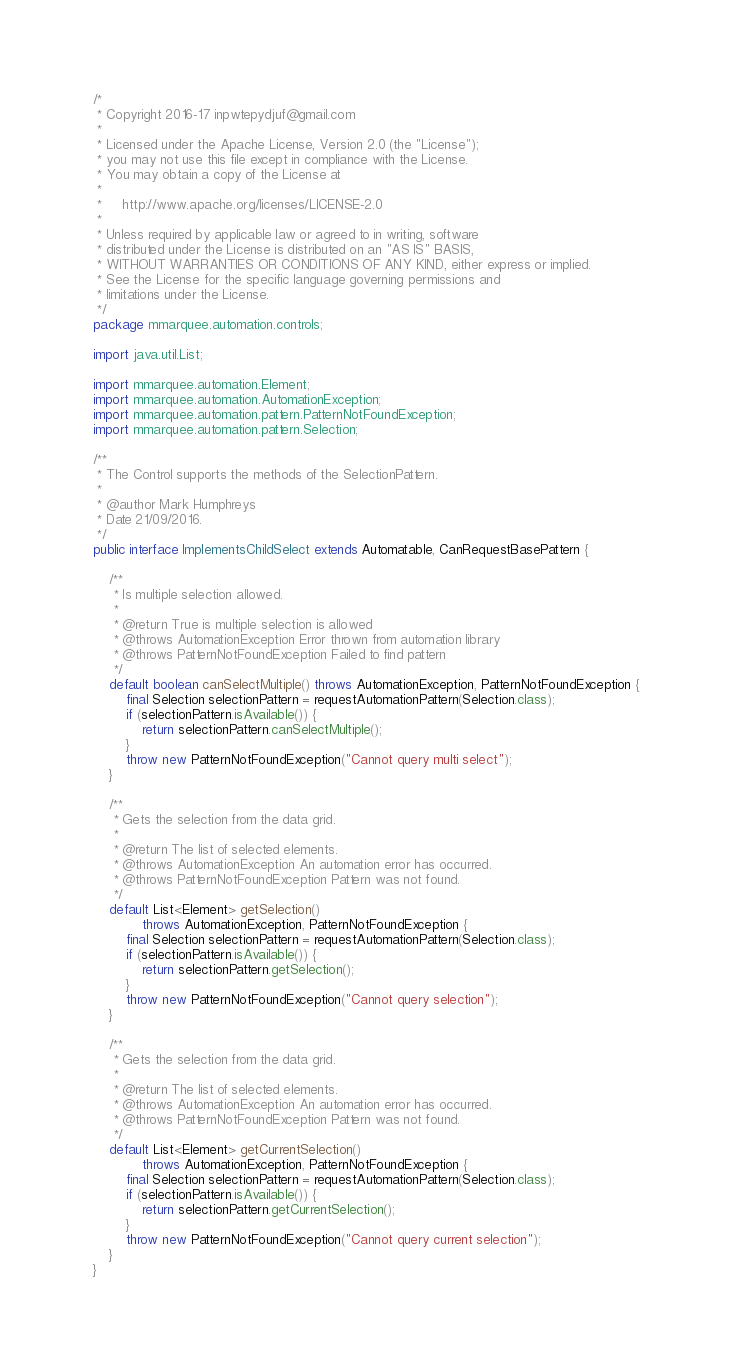<code> <loc_0><loc_0><loc_500><loc_500><_Java_>/*
 * Copyright 2016-17 inpwtepydjuf@gmail.com
 *
 * Licensed under the Apache License, Version 2.0 (the "License");
 * you may not use this file except in compliance with the License.
 * You may obtain a copy of the License at
 *
 *     http://www.apache.org/licenses/LICENSE-2.0
 *
 * Unless required by applicable law or agreed to in writing, software
 * distributed under the License is distributed on an "AS IS" BASIS,
 * WITHOUT WARRANTIES OR CONDITIONS OF ANY KIND, either express or implied.
 * See the License for the specific language governing permissions and
 * limitations under the License.
 */
package mmarquee.automation.controls;

import java.util.List;

import mmarquee.automation.Element;
import mmarquee.automation.AutomationException;
import mmarquee.automation.pattern.PatternNotFoundException;
import mmarquee.automation.pattern.Selection;

/**
 * The Control supports the methods of the SelectionPattern.
 * 
 * @author Mark Humphreys
 * Date 21/09/2016.
 */
public interface ImplementsChildSelect extends Automatable, CanRequestBasePattern {

    /**
     * Is multiple selection allowed.
     *
     * @return True is multiple selection is allowed
     * @throws AutomationException Error thrown from automation library
     * @throws PatternNotFoundException Failed to find pattern
     */
    default boolean canSelectMultiple() throws AutomationException, PatternNotFoundException {
		final Selection selectionPattern = requestAutomationPattern(Selection.class);
		if (selectionPattern.isAvailable()) {
			return selectionPattern.canSelectMultiple();
		}
		throw new PatternNotFoundException("Cannot query multi select");
    }
    
    /**
     * Gets the selection from the data grid.
     *
     * @return The list of selected elements.
     * @throws AutomationException An automation error has occurred.
     * @throws PatternNotFoundException Pattern was not found.
     */
    default List<Element> getSelection()
            throws AutomationException, PatternNotFoundException {
        final Selection selectionPattern = requestAutomationPattern(Selection.class);
		if (selectionPattern.isAvailable()) {
			return selectionPattern.getSelection();
		}
		throw new PatternNotFoundException("Cannot query selection");
    }

    /**
     * Gets the selection from the data grid.
     *
     * @return The list of selected elements.
     * @throws AutomationException An automation error has occurred.
     * @throws PatternNotFoundException Pattern was not found.
     */
    default List<Element> getCurrentSelection()
            throws AutomationException, PatternNotFoundException {
        final Selection selectionPattern = requestAutomationPattern(Selection.class);
		if (selectionPattern.isAvailable()) {
			return selectionPattern.getCurrentSelection();
		}
		throw new PatternNotFoundException("Cannot query current selection");
    }
}
</code> 